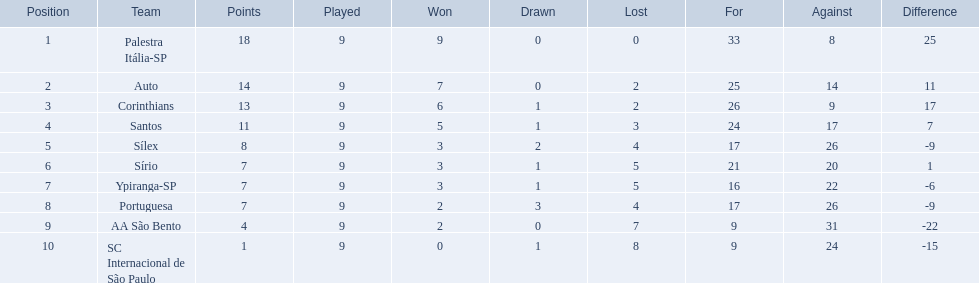Which teams took part in 1926? Palestra Itália-SP, Auto, Corinthians, Santos, Sílex, Sírio, Ypiranga-SP, Portuguesa, AA São Bento, SC Internacional de São Paulo. Did any team experience no losses? Palestra Itália-SP. 